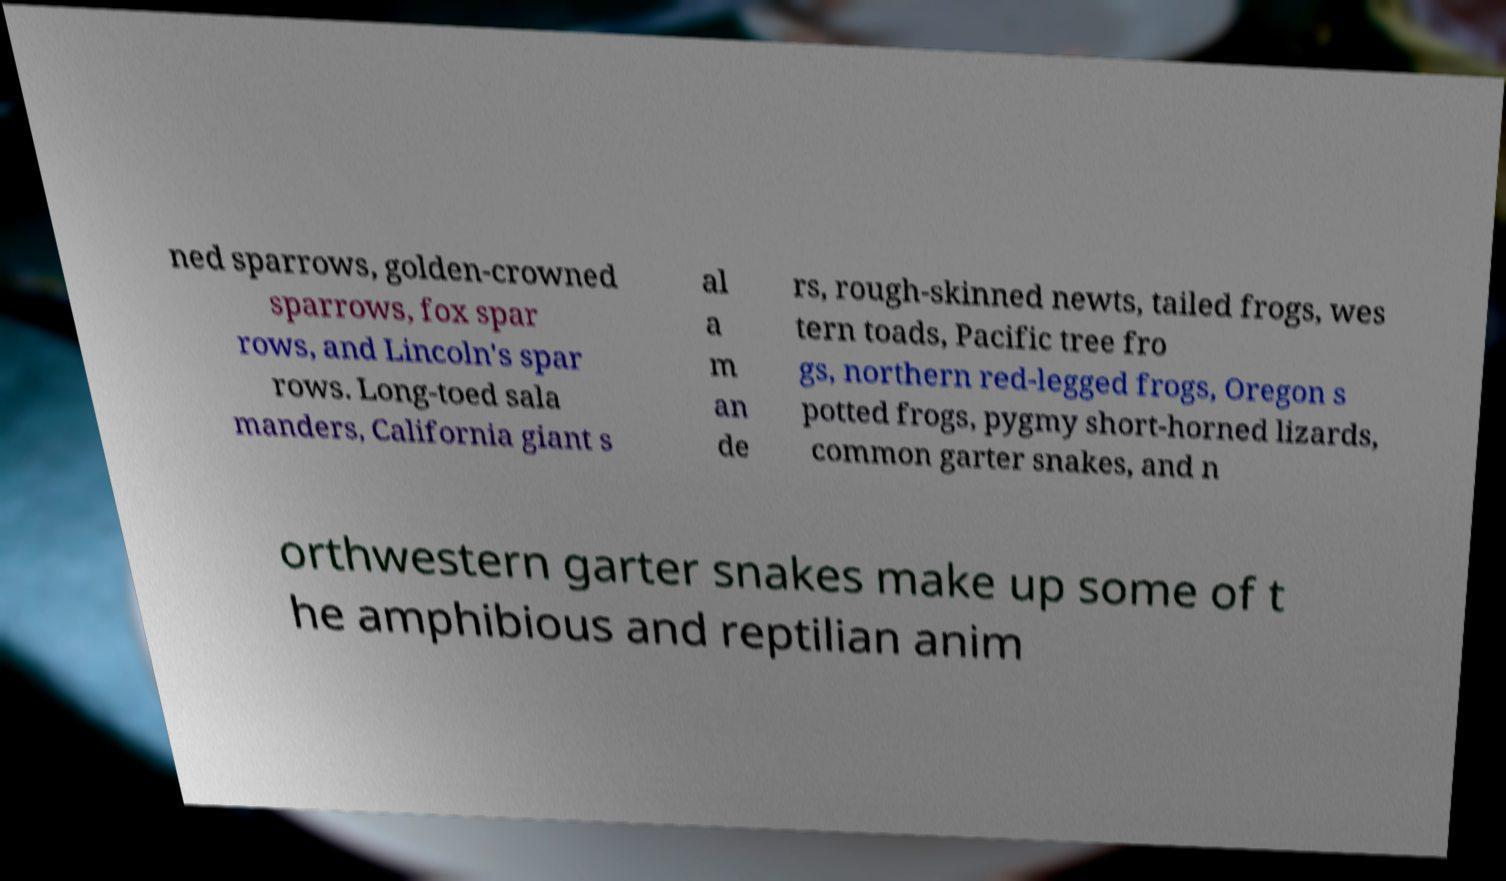Please identify and transcribe the text found in this image. ned sparrows, golden-crowned sparrows, fox spar rows, and Lincoln's spar rows. Long-toed sala manders, California giant s al a m an de rs, rough-skinned newts, tailed frogs, wes tern toads, Pacific tree fro gs, northern red-legged frogs, Oregon s potted frogs, pygmy short-horned lizards, common garter snakes, and n orthwestern garter snakes make up some of t he amphibious and reptilian anim 